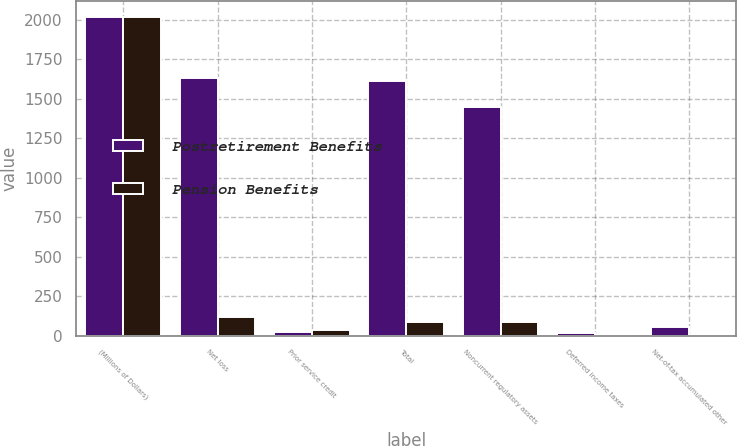Convert chart to OTSL. <chart><loc_0><loc_0><loc_500><loc_500><stacked_bar_chart><ecel><fcel>(Millions of Dollars)<fcel>Net loss<fcel>Prior service credit<fcel>Total<fcel>Noncurrent regulatory assets<fcel>Deferred income taxes<fcel>Net-of-tax accumulated other<nl><fcel>Postretirement Benefits<fcel>2018<fcel>1633<fcel>20<fcel>1613<fcel>1446<fcel>19<fcel>54<nl><fcel>Pension Benefits<fcel>2018<fcel>116<fcel>33<fcel>83<fcel>89<fcel>1<fcel>4<nl></chart> 